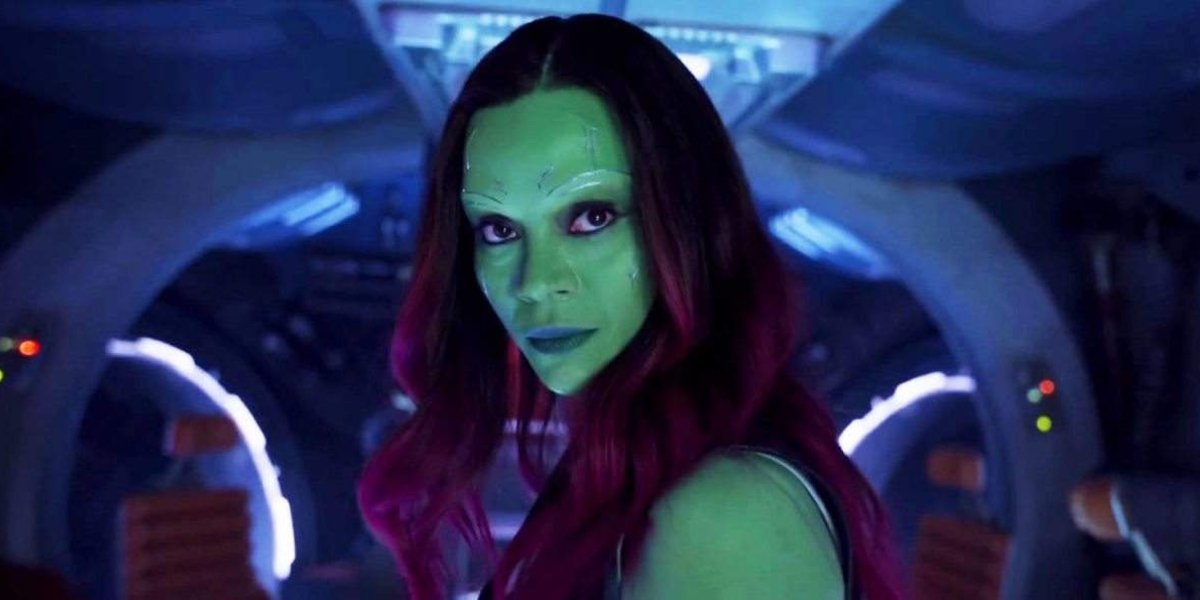How does the character's appearance contribute to the theme of the movie? Her unique appearance with green skin and red hair visually embodies the film's central theme of diversity among cosmic entities. This character often bridges the gap between various alien cultures in the movie, reflecting themes of unity and cooperation amid adversity. Can you expand on how her role impacts the dynamics among other characters? Absolutely. This character serves as both a warrior and a mediator in the movie, often finding herself at the heart of group strategies and decisions. Her strong but compassionate nature influences her interactions with others, making her a key figure in resolving conflicts and leading collaborative efforts among the team. 